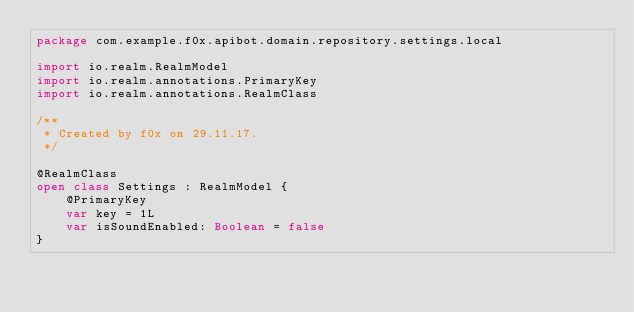<code> <loc_0><loc_0><loc_500><loc_500><_Kotlin_>package com.example.f0x.apibot.domain.repository.settings.local

import io.realm.RealmModel
import io.realm.annotations.PrimaryKey
import io.realm.annotations.RealmClass

/**
 * Created by f0x on 29.11.17.
 */

@RealmClass
open class Settings : RealmModel {
    @PrimaryKey
    var key = 1L
    var isSoundEnabled: Boolean = false
}</code> 